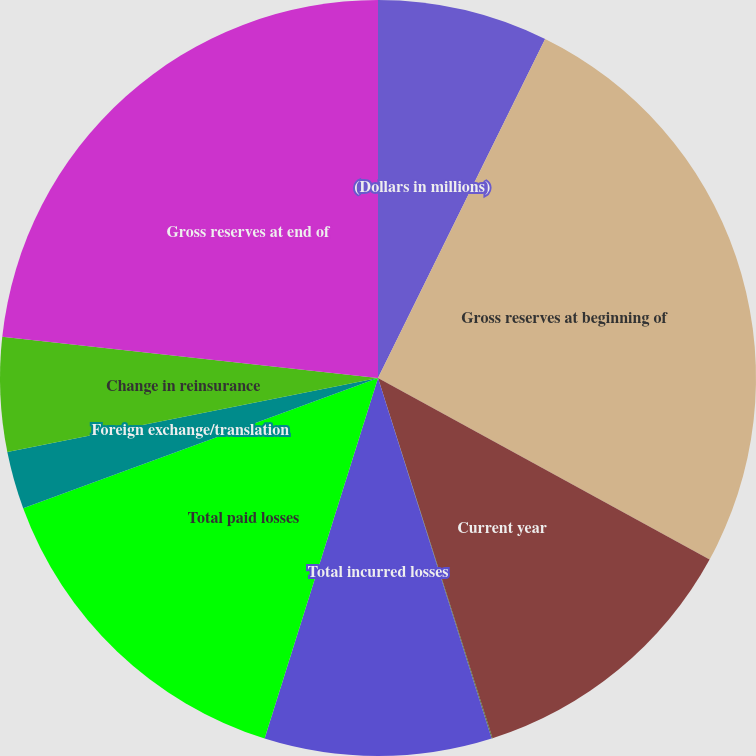<chart> <loc_0><loc_0><loc_500><loc_500><pie_chart><fcel>(Dollars in millions)<fcel>Gross reserves at beginning of<fcel>Current year<fcel>Prior years<fcel>Total incurred losses<fcel>Total paid losses<fcel>Foreign exchange/translation<fcel>Change in reinsurance<fcel>Gross reserves at end of<nl><fcel>7.29%<fcel>25.68%<fcel>12.13%<fcel>0.04%<fcel>9.71%<fcel>14.55%<fcel>2.46%<fcel>4.88%<fcel>23.26%<nl></chart> 